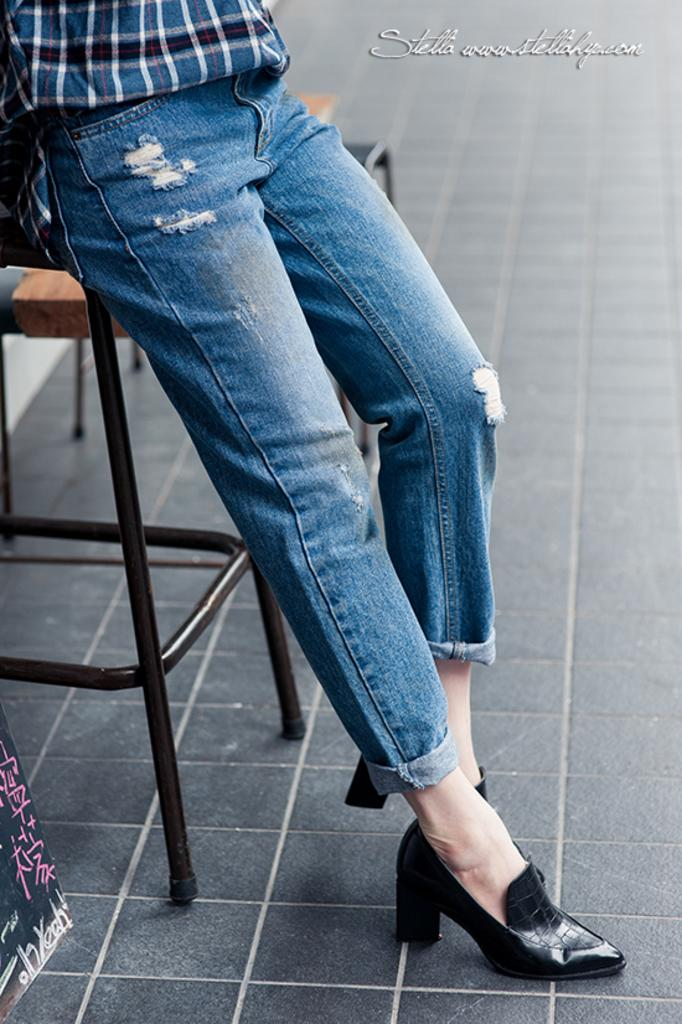Who or what is present in the image? There is a person in the image. What is the person's position in relation to the floor? The person is standing on the floor. Is there any furniture or object that the person is interacting with? Yes, the person is leaning on a stool. What type of tax is being discussed in the image? There is no discussion of tax in the image; it features a person standing and leaning on a stool. 